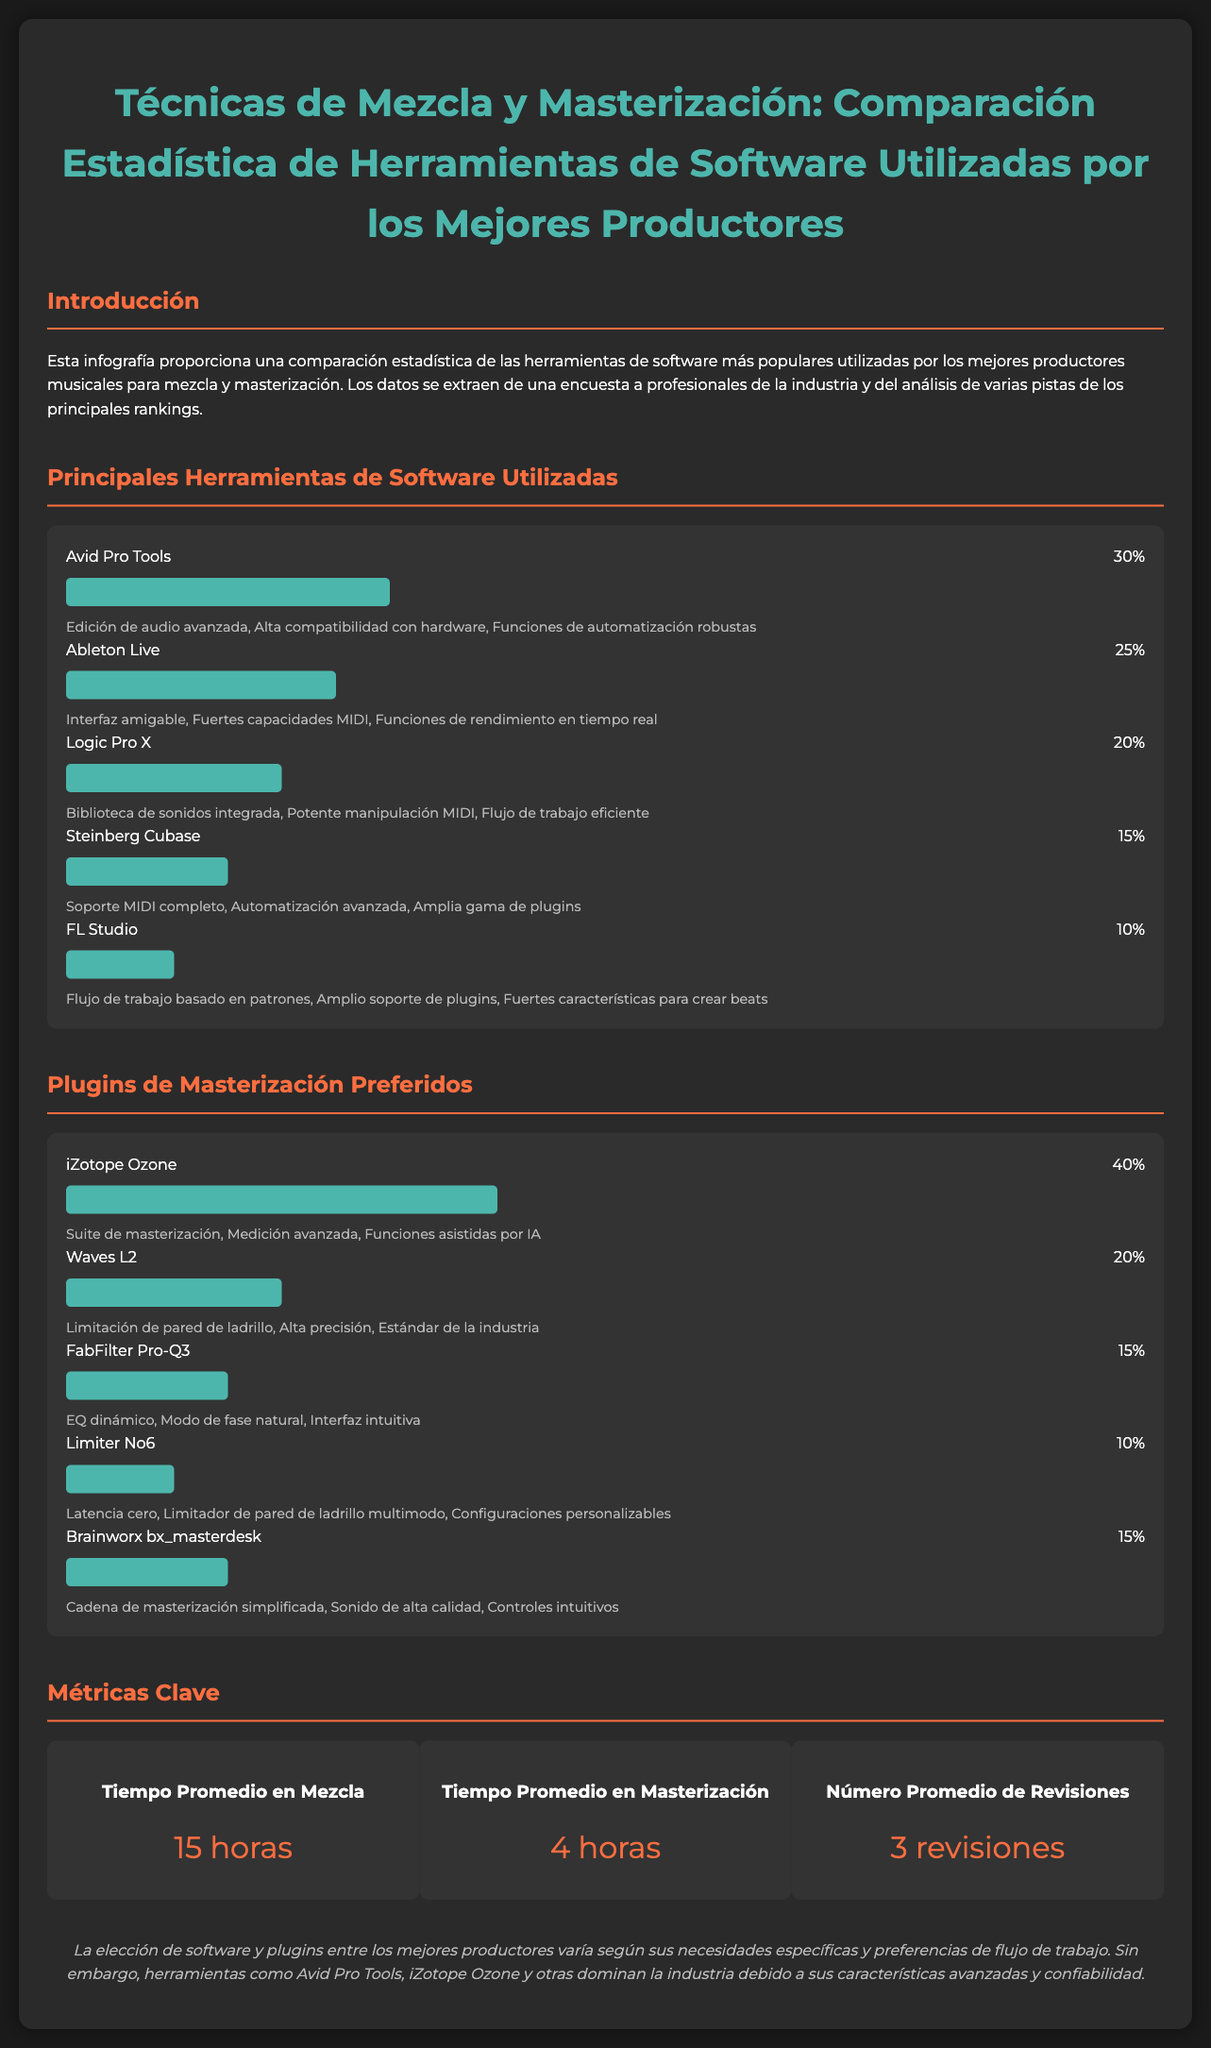¿Qué porcentaje de productores utiliza Avid Pro Tools? Avid Pro Tools representa el 30% del uso entre los productores encuestados.
Answer: 30% ¿Qué características destacan de Ableton Live? Las características claves de Ableton Live incluyen una interfaz amigable, fuertes capacidades MIDI y funciones de rendimiento en tiempo real.
Answer: Interfaz amigable, Fuertes capacidades MIDI, Funciones de rendimiento en tiempo real ¿Cuál es el tiempo promedio destinado a la masterización? El tiempo promedio en masterización, según el documento, es de 4 horas.
Answer: 4 horas ¿Cuál es el plugin de masterización más utilizado? iZotope Ozone es el plugin de masterización más utilizado, con un 40% de preferencia.
Answer: iZotope Ozone ¿Cuántas revisiones son necesarias en promedio? El documento indica que se necesitan, en promedio, 3 revisiones.
Answer: 3 revisiones ¿Qué software tiene el menor porcentaje de uso? FL Studio tiene el menor porcentaje de uso entre los mencionados, con un 10%.
Answer: 10% ¿Qué destaca como una característica clave de Logic Pro X? Una de las características clave de Logic Pro X es su biblioteca de sonidos integrada.
Answer: Biblioteca de sonidos integrada ¿Qué porcentaje de productores utiliza los plugins FabFilter Pro-Q3 y Brainworx bx_masterdesk? FabFilter Pro-Q3 tiene un 15% y Brainworx bx_masterdesk también tiene un 15% en uso.
Answer: 15%, 15% ¿Cuál es la conclusión sobre la elección de software? La conclusión es que la elección de software y plugins varía según las necesidades y preferencias, pero Avid Pro Tools y iZotope Ozone dominan la industria.
Answer: Avid Pro Tools, iZotope Ozone 